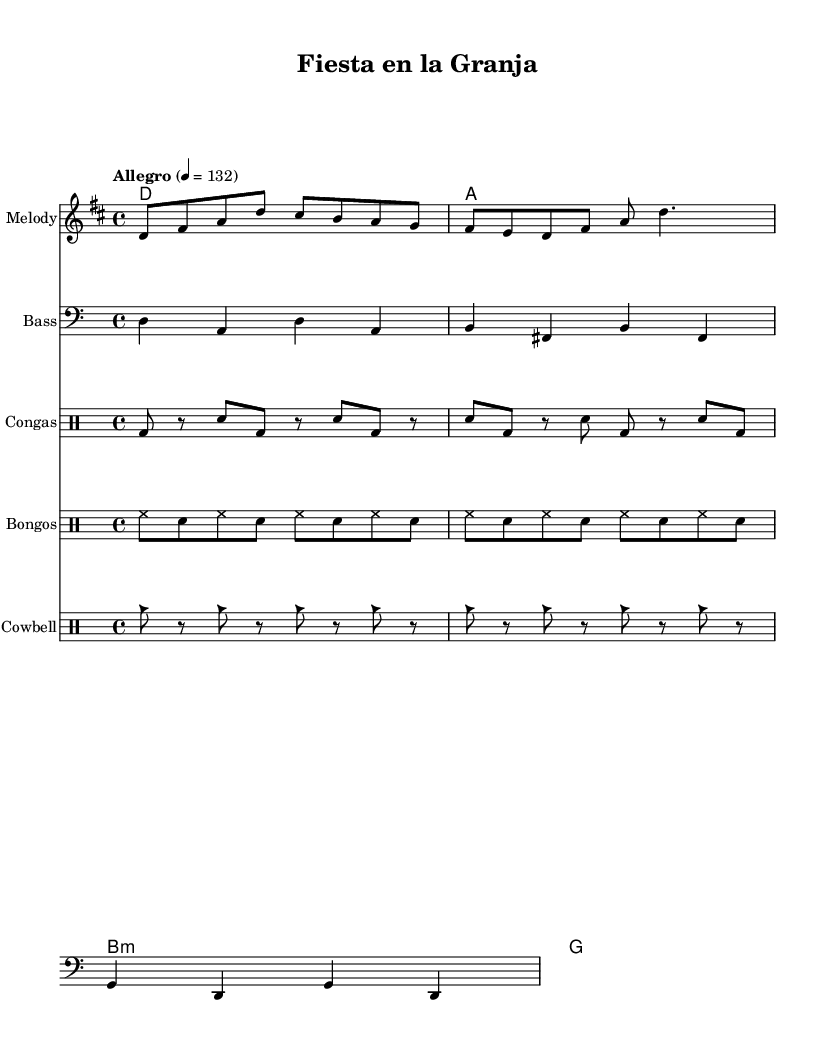What is the key signature of this music? The key signature is indicated at the beginning of the score, and it shows two sharps, which corresponds to D major.
Answer: D major What is the time signature of this piece? The time signature is shown in the beginning of the sheet music, represented by the numbers 4 over 4, indicating there are four beats in each measure.
Answer: 4/4 What is the tempo marking for this piece? The tempo marking is written above the staff and reads "Allegro," with a metronome marking of 132, indicating a fast pace.
Answer: Allegro 132 How many distinct drum parts are included in this score? By examining the score, there are three different drum parts indicated: Congas, Bongos, and Cowbell, each represented on separate staffs.
Answer: Three What is the harmony for the first measure? The first measure of the harmony section shows a D major chord, represented by the letter D in a chord format.
Answer: D Which instrument plays the melody? The melody is written on a staff with the label "Melody," indicating that this part is the main melody line of the composition.
Answer: Melody What rhythmic pattern is used for the cowbell? The cowbell part consists of a repeating pattern alternating between a note and a rest, indicated with the notation cb for a cowbell hit and r for rest.
Answer: cb r 